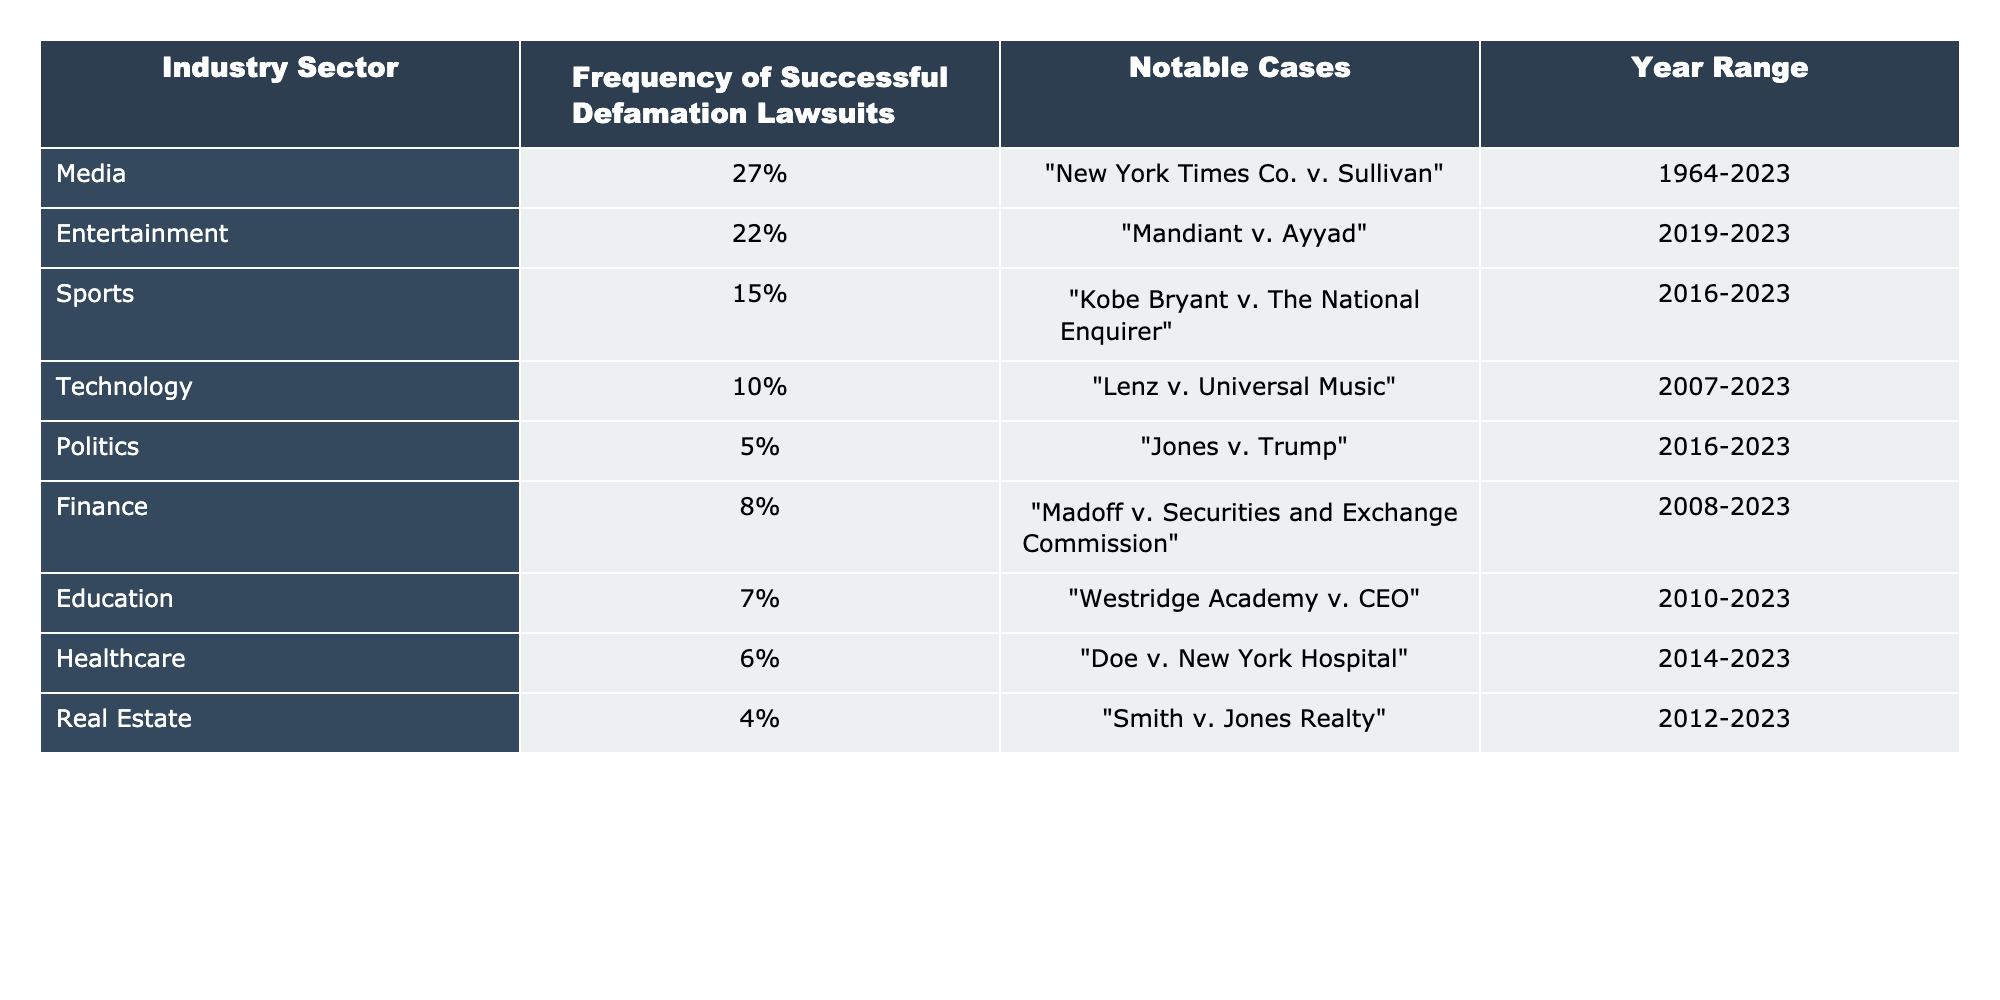What industry sector has the highest frequency of successful defamation lawsuits? Referring to the table, the Media industry sector has the highest frequency of successful defamation lawsuits at 27%.
Answer: Media Which industry sector has the lowest frequency of successful defamation lawsuits? Looking at the table, the Real Estate sector has the lowest frequency of successful defamation lawsuits at 4%.
Answer: Real Estate How many percentage points more frequent are successful defamation lawsuits in the Media sector compared to the Politics sector? The frequency for Media is 27% and for Politics is 5%. The difference is 27% - 5% = 22 percentage points.
Answer: 22 percentage points What is the combined frequency of successful defamation lawsuits for the Finance and Healthcare sectors? The Finance sector has 8% and the Healthcare sector has 6%. Their combined frequency is 8% + 6% = 14%.
Answer: 14% Is it true that the Technology sector has a lower frequency of successful defamation lawsuits than the Sports sector? The Technology sector has a frequency of 10% while the Sports sector has 15%, indicating that Technology has a lower frequency than Sports.
Answer: Yes What is the average frequency of successful defamation lawsuits across the Education, Healthcare, and Real Estate sectors? The frequencies are Education: 7%, Healthcare: 6%, Real Estate: 4%. The average is (7% + 6% + 4%) / 3 = 17% / 3 = 5.67%.
Answer: 5.67% How many industry sectors have a frequency of successful defamation lawsuits greater than 10%? From the table, the sectors with greater than 10% are Media (27%), Entertainment (22%), and Sports (15%), totaling 3 sectors.
Answer: 3 What percentage of successful defamation lawsuits are represented by the Politics sector in relation to the total (sum) of all sectors? The total frequency of all sectors is 27% + 22% + 15% + 10% + 5% + 8% + 7% + 6% + 4% = 104%. The Politics sector (5%) represents 5% out of 104%, which is approximately 4.81%.
Answer: 4.81% If we consider only the top three sectors, what percentage of successful defamation lawsuits do they represent altogether? The top three sectors are Media (27%), Entertainment (22%), and Sports (15%). Together they represent 27% + 22% + 15% = 64%.
Answer: 64% 